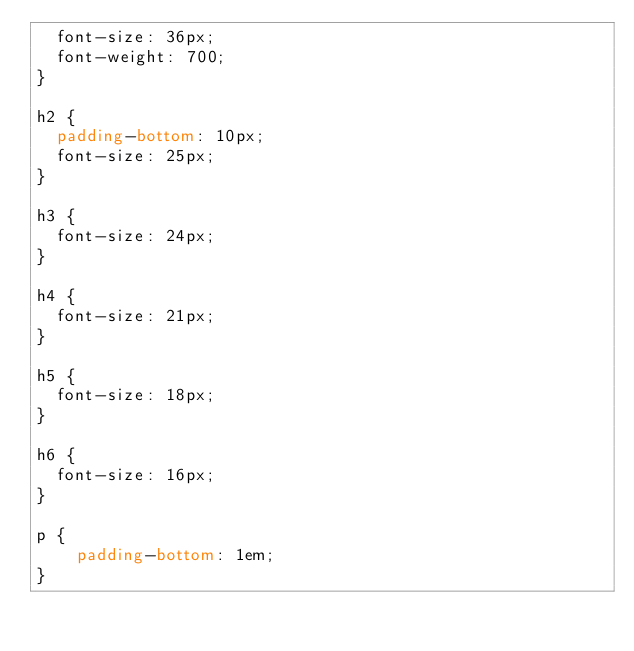<code> <loc_0><loc_0><loc_500><loc_500><_CSS_>  font-size: 36px;
  font-weight: 700;
}

h2 {
  padding-bottom: 10px;
  font-size: 25px;
}

h3 {
  font-size: 24px;
}

h4 {
  font-size: 21px;
}

h5 {
  font-size: 18px;
}

h6 {
  font-size: 16px;
}

p {
    padding-bottom: 1em;
}</code> 